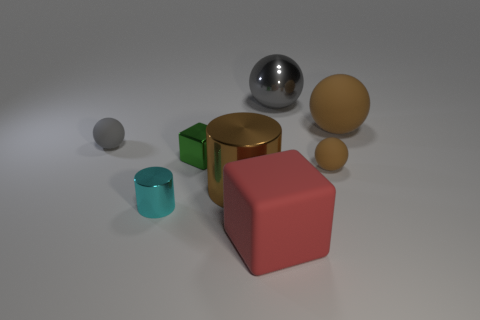Add 2 large brown spheres. How many objects exist? 10 Subtract all cylinders. How many objects are left? 6 Add 1 big brown metallic cylinders. How many big brown metallic cylinders are left? 2 Add 8 tiny green balls. How many tiny green balls exist? 8 Subtract 0 cyan balls. How many objects are left? 8 Subtract all big brown rubber spheres. Subtract all big brown rubber spheres. How many objects are left? 6 